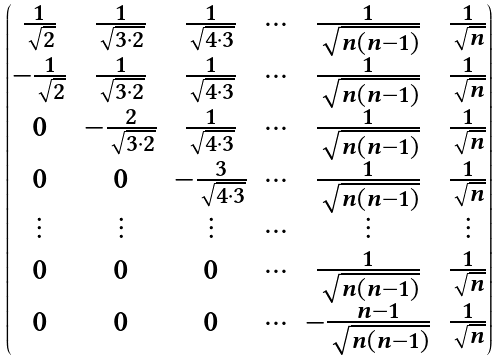<formula> <loc_0><loc_0><loc_500><loc_500>\begin{pmatrix} \frac { 1 } { \sqrt { 2 } } & \frac { 1 } { \sqrt { 3 \cdot 2 } } & \frac { 1 } { \sqrt { 4 \cdot 3 } } & \cdots & \frac { 1 } { \sqrt { n ( n - 1 ) } } & \frac { 1 } { \sqrt { n } } \\ - \frac { 1 } { \sqrt { 2 } } & \frac { 1 } { \sqrt { 3 \cdot 2 } } & \frac { 1 } { \sqrt { 4 \cdot 3 } } & \cdots & \frac { 1 } { \sqrt { n ( n - 1 ) } } & \frac { 1 } { \sqrt { n } } \\ 0 & - \frac { 2 } { \sqrt { 3 \cdot 2 } } & \frac { 1 } { \sqrt { 4 \cdot 3 } } & \cdots & \frac { 1 } { \sqrt { n ( n - 1 ) } } & \frac { 1 } { \sqrt { n } } \\ 0 & 0 & - \frac { 3 } { \sqrt { 4 \cdot 3 } } & \cdots & \frac { 1 } { \sqrt { n ( n - 1 ) } } & \frac { 1 } { \sqrt { n } } \\ \vdots & \vdots & \vdots & \cdots & \vdots & \vdots \\ 0 & 0 & 0 & \cdots & \frac { 1 } { \sqrt { n ( n - 1 ) } } & \frac { 1 } { \sqrt { n } } \\ 0 & 0 & 0 & \cdots & - \frac { n - 1 } { \sqrt { n ( n - 1 ) } } & \frac { 1 } { \sqrt { n } } \end{pmatrix}</formula> 